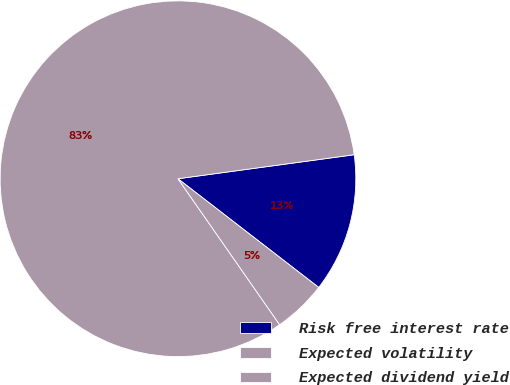Convert chart to OTSL. <chart><loc_0><loc_0><loc_500><loc_500><pie_chart><fcel>Risk free interest rate<fcel>Expected volatility<fcel>Expected dividend yield<nl><fcel>12.62%<fcel>82.52%<fcel>4.85%<nl></chart> 